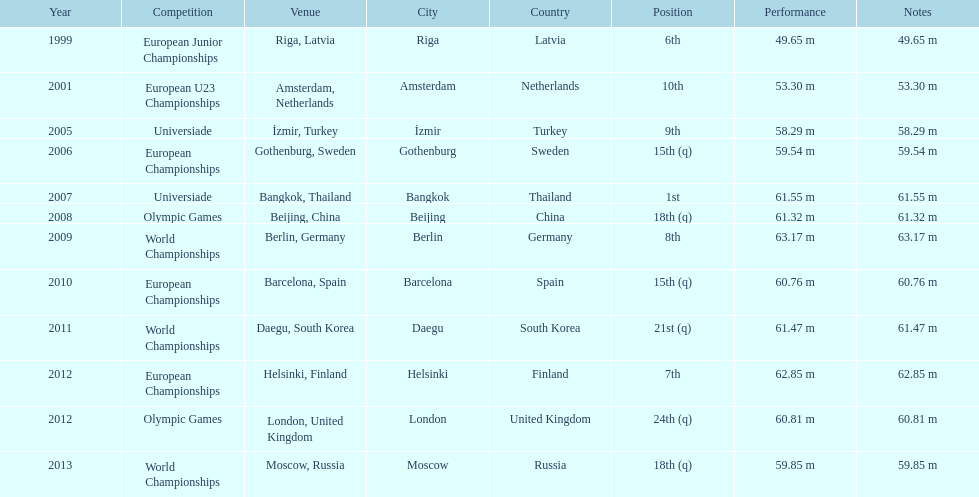What was mayer's best result: i.e his longest throw? 63.17 m. 